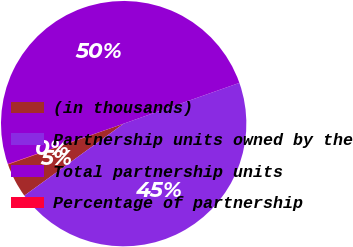Convert chart. <chart><loc_0><loc_0><loc_500><loc_500><pie_chart><fcel>(in thousands)<fcel>Partnership units owned by the<fcel>Total partnership units<fcel>Percentage of partnership<nl><fcel>4.59%<fcel>45.41%<fcel>49.95%<fcel>0.05%<nl></chart> 